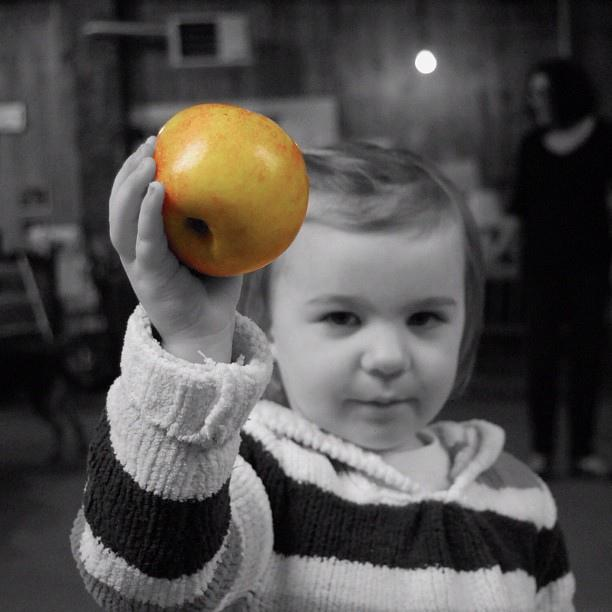What happens to the image? photoshopped 